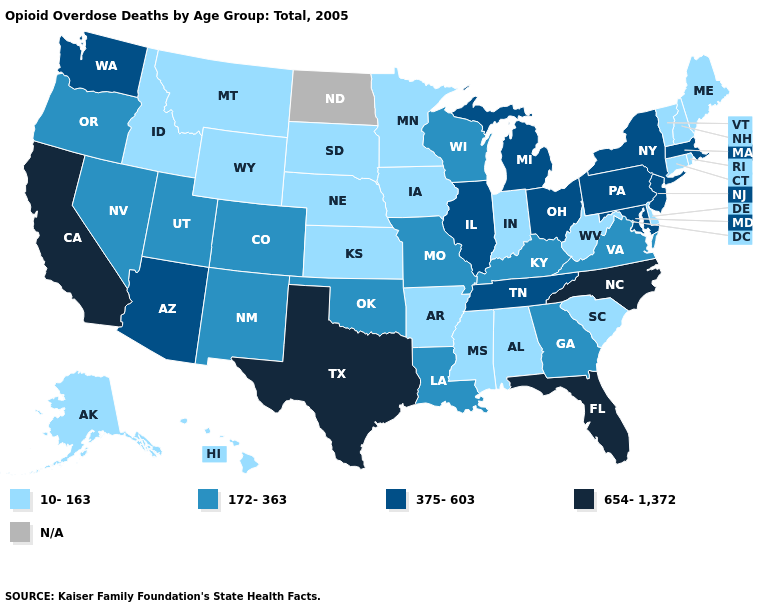Which states have the highest value in the USA?
Answer briefly. California, Florida, North Carolina, Texas. Name the states that have a value in the range 172-363?
Give a very brief answer. Colorado, Georgia, Kentucky, Louisiana, Missouri, Nevada, New Mexico, Oklahoma, Oregon, Utah, Virginia, Wisconsin. Among the states that border Washington , which have the highest value?
Short answer required. Oregon. Among the states that border Missouri , which have the highest value?
Short answer required. Illinois, Tennessee. Name the states that have a value in the range N/A?
Be succinct. North Dakota. Name the states that have a value in the range 172-363?
Be succinct. Colorado, Georgia, Kentucky, Louisiana, Missouri, Nevada, New Mexico, Oklahoma, Oregon, Utah, Virginia, Wisconsin. What is the value of Alabama?
Answer briefly. 10-163. Name the states that have a value in the range N/A?
Be succinct. North Dakota. What is the lowest value in states that border Oklahoma?
Be succinct. 10-163. Name the states that have a value in the range 654-1,372?
Concise answer only. California, Florida, North Carolina, Texas. What is the highest value in the Northeast ?
Be succinct. 375-603. What is the value of Ohio?
Concise answer only. 375-603. Name the states that have a value in the range 375-603?
Short answer required. Arizona, Illinois, Maryland, Massachusetts, Michigan, New Jersey, New York, Ohio, Pennsylvania, Tennessee, Washington. Name the states that have a value in the range 654-1,372?
Keep it brief. California, Florida, North Carolina, Texas. Name the states that have a value in the range 10-163?
Write a very short answer. Alabama, Alaska, Arkansas, Connecticut, Delaware, Hawaii, Idaho, Indiana, Iowa, Kansas, Maine, Minnesota, Mississippi, Montana, Nebraska, New Hampshire, Rhode Island, South Carolina, South Dakota, Vermont, West Virginia, Wyoming. 